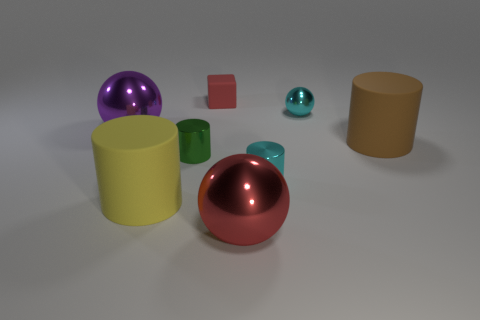How many large purple metallic objects are the same shape as the yellow matte object?
Provide a succinct answer. 0. What is the shape of the big purple object that is made of the same material as the red ball?
Make the answer very short. Sphere. The large object right of the big metallic thing that is on the right side of the purple sphere is what color?
Give a very brief answer. Brown. Is the tiny cube the same color as the small metal ball?
Your response must be concise. No. There is a cyan object that is behind the big shiny sphere left of the red matte thing; what is its material?
Your answer should be compact. Metal. There is a brown object that is the same shape as the large yellow matte object; what is it made of?
Keep it short and to the point. Rubber. Are there any purple balls right of the rubber cylinder that is on the right side of the big rubber object to the left of the brown object?
Make the answer very short. No. What number of other objects are the same color as the tiny rubber cube?
Your answer should be very brief. 1. What number of big matte things are both in front of the large brown matte cylinder and right of the tiny green thing?
Ensure brevity in your answer.  0. What shape is the green metallic thing?
Ensure brevity in your answer.  Cylinder. 